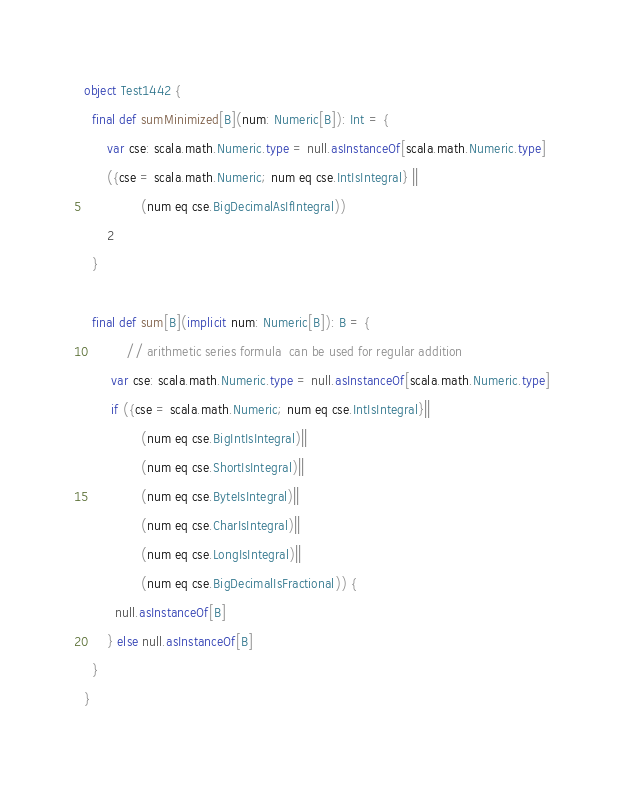Convert code to text. <code><loc_0><loc_0><loc_500><loc_500><_Scala_>object Test1442 {
  final def sumMinimized[B](num: Numeric[B]): Int = {
      var cse: scala.math.Numeric.type = null.asInstanceOf[scala.math.Numeric.type]
      ({cse = scala.math.Numeric; num eq cse.IntIsIntegral} ||
               (num eq cse.BigDecimalAsIfIntegral))
      2
  }

  final def sum[B](implicit num: Numeric[B]): B = {
           // arithmetic series formula  can be used for regular addition
       var cse: scala.math.Numeric.type = null.asInstanceOf[scala.math.Numeric.type]
       if ({cse = scala.math.Numeric; num eq cse.IntIsIntegral}||
               (num eq cse.BigIntIsIntegral)||
               (num eq cse.ShortIsIntegral)||
               (num eq cse.ByteIsIntegral)||
               (num eq cse.CharIsIntegral)||
               (num eq cse.LongIsIntegral)||
               (num eq cse.BigDecimalIsFractional)) {
        null.asInstanceOf[B]
      } else null.asInstanceOf[B]
  }
}
</code> 